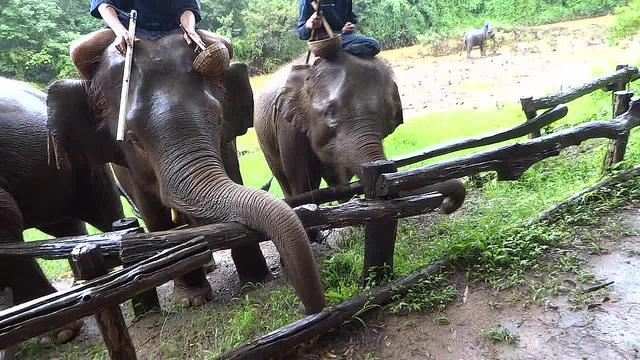What animals are present in the image?

Choices:
A) elephant
B) giraffe
C) tiger
D) bear elephant 